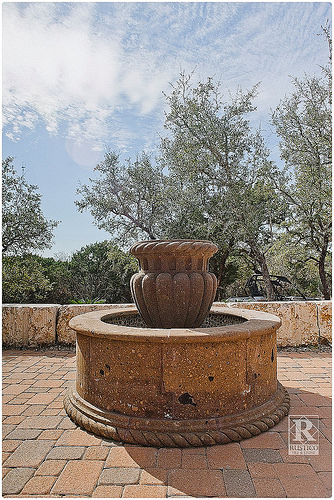<image>
Can you confirm if the vase is on the ground? No. The vase is not positioned on the ground. They may be near each other, but the vase is not supported by or resting on top of the ground. Is there a fountain to the right of the fountain? No. The fountain is not to the right of the fountain. The horizontal positioning shows a different relationship. 